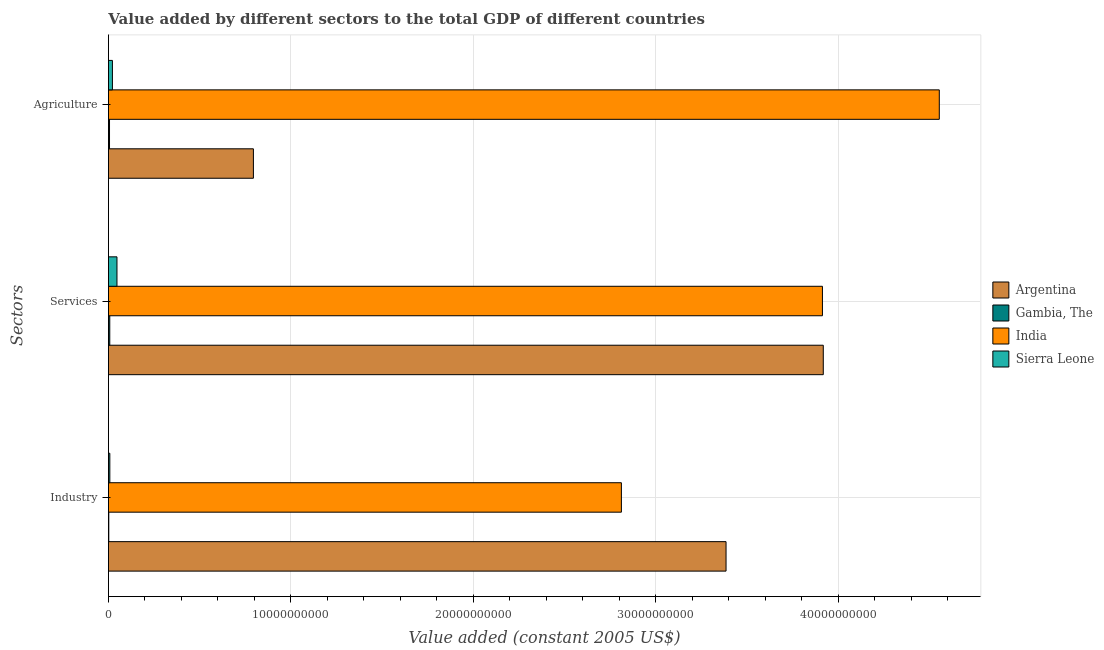Are the number of bars per tick equal to the number of legend labels?
Provide a succinct answer. Yes. How many bars are there on the 2nd tick from the top?
Provide a short and direct response. 4. What is the label of the 3rd group of bars from the top?
Make the answer very short. Industry. What is the value added by industrial sector in India?
Offer a very short reply. 2.81e+1. Across all countries, what is the maximum value added by services?
Your answer should be very brief. 3.92e+1. Across all countries, what is the minimum value added by industrial sector?
Make the answer very short. 2.00e+07. In which country was the value added by agricultural sector maximum?
Make the answer very short. India. In which country was the value added by agricultural sector minimum?
Offer a terse response. Gambia, The. What is the total value added by industrial sector in the graph?
Offer a terse response. 6.21e+1. What is the difference between the value added by services in Argentina and that in India?
Offer a terse response. 4.61e+07. What is the difference between the value added by industrial sector in Argentina and the value added by agricultural sector in Sierra Leone?
Your answer should be very brief. 3.36e+1. What is the average value added by agricultural sector per country?
Offer a terse response. 1.34e+1. What is the difference between the value added by industrial sector and value added by services in India?
Ensure brevity in your answer.  -1.10e+1. What is the ratio of the value added by industrial sector in Gambia, The to that in Argentina?
Your response must be concise. 0. What is the difference between the highest and the second highest value added by services?
Give a very brief answer. 4.61e+07. What is the difference between the highest and the lowest value added by services?
Your answer should be compact. 3.91e+1. In how many countries, is the value added by industrial sector greater than the average value added by industrial sector taken over all countries?
Your response must be concise. 2. What does the 2nd bar from the bottom in Services represents?
Provide a short and direct response. Gambia, The. How many countries are there in the graph?
Make the answer very short. 4. What is the difference between two consecutive major ticks on the X-axis?
Provide a succinct answer. 1.00e+1. Does the graph contain any zero values?
Give a very brief answer. No. Where does the legend appear in the graph?
Offer a very short reply. Center right. How many legend labels are there?
Offer a terse response. 4. How are the legend labels stacked?
Provide a short and direct response. Vertical. What is the title of the graph?
Your answer should be very brief. Value added by different sectors to the total GDP of different countries. Does "Kyrgyz Republic" appear as one of the legend labels in the graph?
Your answer should be compact. No. What is the label or title of the X-axis?
Offer a terse response. Value added (constant 2005 US$). What is the label or title of the Y-axis?
Ensure brevity in your answer.  Sectors. What is the Value added (constant 2005 US$) in Argentina in Industry?
Ensure brevity in your answer.  3.39e+1. What is the Value added (constant 2005 US$) in Gambia, The in Industry?
Offer a terse response. 2.00e+07. What is the Value added (constant 2005 US$) of India in Industry?
Provide a short and direct response. 2.81e+1. What is the Value added (constant 2005 US$) of Sierra Leone in Industry?
Give a very brief answer. 7.63e+07. What is the Value added (constant 2005 US$) in Argentina in Services?
Your answer should be compact. 3.92e+1. What is the Value added (constant 2005 US$) of Gambia, The in Services?
Your response must be concise. 7.31e+07. What is the Value added (constant 2005 US$) in India in Services?
Offer a terse response. 3.91e+1. What is the Value added (constant 2005 US$) of Sierra Leone in Services?
Your response must be concise. 4.68e+08. What is the Value added (constant 2005 US$) in Argentina in Agriculture?
Provide a succinct answer. 7.95e+09. What is the Value added (constant 2005 US$) in Gambia, The in Agriculture?
Offer a terse response. 5.97e+07. What is the Value added (constant 2005 US$) in India in Agriculture?
Provide a succinct answer. 4.55e+1. What is the Value added (constant 2005 US$) in Sierra Leone in Agriculture?
Your response must be concise. 2.19e+08. Across all Sectors, what is the maximum Value added (constant 2005 US$) of Argentina?
Ensure brevity in your answer.  3.92e+1. Across all Sectors, what is the maximum Value added (constant 2005 US$) of Gambia, The?
Offer a terse response. 7.31e+07. Across all Sectors, what is the maximum Value added (constant 2005 US$) of India?
Your answer should be compact. 4.55e+1. Across all Sectors, what is the maximum Value added (constant 2005 US$) of Sierra Leone?
Provide a succinct answer. 4.68e+08. Across all Sectors, what is the minimum Value added (constant 2005 US$) in Argentina?
Offer a terse response. 7.95e+09. Across all Sectors, what is the minimum Value added (constant 2005 US$) of Gambia, The?
Ensure brevity in your answer.  2.00e+07. Across all Sectors, what is the minimum Value added (constant 2005 US$) of India?
Your answer should be compact. 2.81e+1. Across all Sectors, what is the minimum Value added (constant 2005 US$) of Sierra Leone?
Ensure brevity in your answer.  7.63e+07. What is the total Value added (constant 2005 US$) in Argentina in the graph?
Offer a very short reply. 8.10e+1. What is the total Value added (constant 2005 US$) in Gambia, The in the graph?
Your answer should be very brief. 1.53e+08. What is the total Value added (constant 2005 US$) of India in the graph?
Offer a terse response. 1.13e+11. What is the total Value added (constant 2005 US$) of Sierra Leone in the graph?
Ensure brevity in your answer.  7.63e+08. What is the difference between the Value added (constant 2005 US$) in Argentina in Industry and that in Services?
Provide a short and direct response. -5.33e+09. What is the difference between the Value added (constant 2005 US$) in Gambia, The in Industry and that in Services?
Offer a very short reply. -5.31e+07. What is the difference between the Value added (constant 2005 US$) of India in Industry and that in Services?
Keep it short and to the point. -1.10e+1. What is the difference between the Value added (constant 2005 US$) in Sierra Leone in Industry and that in Services?
Offer a terse response. -3.92e+08. What is the difference between the Value added (constant 2005 US$) of Argentina in Industry and that in Agriculture?
Ensure brevity in your answer.  2.59e+1. What is the difference between the Value added (constant 2005 US$) of Gambia, The in Industry and that in Agriculture?
Your answer should be compact. -3.97e+07. What is the difference between the Value added (constant 2005 US$) in India in Industry and that in Agriculture?
Provide a short and direct response. -1.74e+1. What is the difference between the Value added (constant 2005 US$) in Sierra Leone in Industry and that in Agriculture?
Provide a succinct answer. -1.42e+08. What is the difference between the Value added (constant 2005 US$) in Argentina in Services and that in Agriculture?
Your answer should be compact. 3.12e+1. What is the difference between the Value added (constant 2005 US$) in Gambia, The in Services and that in Agriculture?
Ensure brevity in your answer.  1.34e+07. What is the difference between the Value added (constant 2005 US$) of India in Services and that in Agriculture?
Provide a succinct answer. -6.41e+09. What is the difference between the Value added (constant 2005 US$) in Sierra Leone in Services and that in Agriculture?
Make the answer very short. 2.50e+08. What is the difference between the Value added (constant 2005 US$) in Argentina in Industry and the Value added (constant 2005 US$) in Gambia, The in Services?
Your answer should be compact. 3.38e+1. What is the difference between the Value added (constant 2005 US$) in Argentina in Industry and the Value added (constant 2005 US$) in India in Services?
Provide a succinct answer. -5.28e+09. What is the difference between the Value added (constant 2005 US$) of Argentina in Industry and the Value added (constant 2005 US$) of Sierra Leone in Services?
Provide a short and direct response. 3.34e+1. What is the difference between the Value added (constant 2005 US$) in Gambia, The in Industry and the Value added (constant 2005 US$) in India in Services?
Your answer should be compact. -3.91e+1. What is the difference between the Value added (constant 2005 US$) in Gambia, The in Industry and the Value added (constant 2005 US$) in Sierra Leone in Services?
Make the answer very short. -4.48e+08. What is the difference between the Value added (constant 2005 US$) of India in Industry and the Value added (constant 2005 US$) of Sierra Leone in Services?
Ensure brevity in your answer.  2.77e+1. What is the difference between the Value added (constant 2005 US$) of Argentina in Industry and the Value added (constant 2005 US$) of Gambia, The in Agriculture?
Your answer should be very brief. 3.38e+1. What is the difference between the Value added (constant 2005 US$) in Argentina in Industry and the Value added (constant 2005 US$) in India in Agriculture?
Your answer should be very brief. -1.17e+1. What is the difference between the Value added (constant 2005 US$) of Argentina in Industry and the Value added (constant 2005 US$) of Sierra Leone in Agriculture?
Make the answer very short. 3.36e+1. What is the difference between the Value added (constant 2005 US$) in Gambia, The in Industry and the Value added (constant 2005 US$) in India in Agriculture?
Keep it short and to the point. -4.55e+1. What is the difference between the Value added (constant 2005 US$) of Gambia, The in Industry and the Value added (constant 2005 US$) of Sierra Leone in Agriculture?
Offer a very short reply. -1.99e+08. What is the difference between the Value added (constant 2005 US$) of India in Industry and the Value added (constant 2005 US$) of Sierra Leone in Agriculture?
Offer a terse response. 2.79e+1. What is the difference between the Value added (constant 2005 US$) in Argentina in Services and the Value added (constant 2005 US$) in Gambia, The in Agriculture?
Make the answer very short. 3.91e+1. What is the difference between the Value added (constant 2005 US$) in Argentina in Services and the Value added (constant 2005 US$) in India in Agriculture?
Make the answer very short. -6.36e+09. What is the difference between the Value added (constant 2005 US$) of Argentina in Services and the Value added (constant 2005 US$) of Sierra Leone in Agriculture?
Make the answer very short. 3.90e+1. What is the difference between the Value added (constant 2005 US$) of Gambia, The in Services and the Value added (constant 2005 US$) of India in Agriculture?
Your response must be concise. -4.55e+1. What is the difference between the Value added (constant 2005 US$) in Gambia, The in Services and the Value added (constant 2005 US$) in Sierra Leone in Agriculture?
Give a very brief answer. -1.45e+08. What is the difference between the Value added (constant 2005 US$) in India in Services and the Value added (constant 2005 US$) in Sierra Leone in Agriculture?
Keep it short and to the point. 3.89e+1. What is the average Value added (constant 2005 US$) of Argentina per Sectors?
Provide a short and direct response. 2.70e+1. What is the average Value added (constant 2005 US$) of Gambia, The per Sectors?
Make the answer very short. 5.09e+07. What is the average Value added (constant 2005 US$) of India per Sectors?
Provide a short and direct response. 3.76e+1. What is the average Value added (constant 2005 US$) of Sierra Leone per Sectors?
Your answer should be very brief. 2.54e+08. What is the difference between the Value added (constant 2005 US$) in Argentina and Value added (constant 2005 US$) in Gambia, The in Industry?
Provide a short and direct response. 3.38e+1. What is the difference between the Value added (constant 2005 US$) in Argentina and Value added (constant 2005 US$) in India in Industry?
Give a very brief answer. 5.74e+09. What is the difference between the Value added (constant 2005 US$) of Argentina and Value added (constant 2005 US$) of Sierra Leone in Industry?
Your answer should be compact. 3.38e+1. What is the difference between the Value added (constant 2005 US$) of Gambia, The and Value added (constant 2005 US$) of India in Industry?
Your answer should be compact. -2.81e+1. What is the difference between the Value added (constant 2005 US$) of Gambia, The and Value added (constant 2005 US$) of Sierra Leone in Industry?
Offer a terse response. -5.63e+07. What is the difference between the Value added (constant 2005 US$) of India and Value added (constant 2005 US$) of Sierra Leone in Industry?
Your answer should be very brief. 2.80e+1. What is the difference between the Value added (constant 2005 US$) in Argentina and Value added (constant 2005 US$) in Gambia, The in Services?
Provide a succinct answer. 3.91e+1. What is the difference between the Value added (constant 2005 US$) of Argentina and Value added (constant 2005 US$) of India in Services?
Make the answer very short. 4.61e+07. What is the difference between the Value added (constant 2005 US$) of Argentina and Value added (constant 2005 US$) of Sierra Leone in Services?
Offer a very short reply. 3.87e+1. What is the difference between the Value added (constant 2005 US$) of Gambia, The and Value added (constant 2005 US$) of India in Services?
Offer a very short reply. -3.91e+1. What is the difference between the Value added (constant 2005 US$) in Gambia, The and Value added (constant 2005 US$) in Sierra Leone in Services?
Your answer should be very brief. -3.95e+08. What is the difference between the Value added (constant 2005 US$) in India and Value added (constant 2005 US$) in Sierra Leone in Services?
Ensure brevity in your answer.  3.87e+1. What is the difference between the Value added (constant 2005 US$) of Argentina and Value added (constant 2005 US$) of Gambia, The in Agriculture?
Give a very brief answer. 7.89e+09. What is the difference between the Value added (constant 2005 US$) of Argentina and Value added (constant 2005 US$) of India in Agriculture?
Provide a succinct answer. -3.76e+1. What is the difference between the Value added (constant 2005 US$) in Argentina and Value added (constant 2005 US$) in Sierra Leone in Agriculture?
Your answer should be compact. 7.73e+09. What is the difference between the Value added (constant 2005 US$) in Gambia, The and Value added (constant 2005 US$) in India in Agriculture?
Provide a succinct answer. -4.55e+1. What is the difference between the Value added (constant 2005 US$) of Gambia, The and Value added (constant 2005 US$) of Sierra Leone in Agriculture?
Keep it short and to the point. -1.59e+08. What is the difference between the Value added (constant 2005 US$) of India and Value added (constant 2005 US$) of Sierra Leone in Agriculture?
Give a very brief answer. 4.53e+1. What is the ratio of the Value added (constant 2005 US$) in Argentina in Industry to that in Services?
Make the answer very short. 0.86. What is the ratio of the Value added (constant 2005 US$) in Gambia, The in Industry to that in Services?
Provide a short and direct response. 0.27. What is the ratio of the Value added (constant 2005 US$) of India in Industry to that in Services?
Provide a short and direct response. 0.72. What is the ratio of the Value added (constant 2005 US$) of Sierra Leone in Industry to that in Services?
Keep it short and to the point. 0.16. What is the ratio of the Value added (constant 2005 US$) of Argentina in Industry to that in Agriculture?
Make the answer very short. 4.26. What is the ratio of the Value added (constant 2005 US$) of Gambia, The in Industry to that in Agriculture?
Make the answer very short. 0.34. What is the ratio of the Value added (constant 2005 US$) in India in Industry to that in Agriculture?
Give a very brief answer. 0.62. What is the ratio of the Value added (constant 2005 US$) in Sierra Leone in Industry to that in Agriculture?
Provide a succinct answer. 0.35. What is the ratio of the Value added (constant 2005 US$) of Argentina in Services to that in Agriculture?
Offer a very short reply. 4.93. What is the ratio of the Value added (constant 2005 US$) of Gambia, The in Services to that in Agriculture?
Your answer should be compact. 1.22. What is the ratio of the Value added (constant 2005 US$) in India in Services to that in Agriculture?
Ensure brevity in your answer.  0.86. What is the ratio of the Value added (constant 2005 US$) in Sierra Leone in Services to that in Agriculture?
Your answer should be compact. 2.14. What is the difference between the highest and the second highest Value added (constant 2005 US$) of Argentina?
Offer a terse response. 5.33e+09. What is the difference between the highest and the second highest Value added (constant 2005 US$) in Gambia, The?
Your answer should be compact. 1.34e+07. What is the difference between the highest and the second highest Value added (constant 2005 US$) in India?
Ensure brevity in your answer.  6.41e+09. What is the difference between the highest and the second highest Value added (constant 2005 US$) of Sierra Leone?
Keep it short and to the point. 2.50e+08. What is the difference between the highest and the lowest Value added (constant 2005 US$) of Argentina?
Ensure brevity in your answer.  3.12e+1. What is the difference between the highest and the lowest Value added (constant 2005 US$) in Gambia, The?
Ensure brevity in your answer.  5.31e+07. What is the difference between the highest and the lowest Value added (constant 2005 US$) in India?
Ensure brevity in your answer.  1.74e+1. What is the difference between the highest and the lowest Value added (constant 2005 US$) in Sierra Leone?
Offer a very short reply. 3.92e+08. 